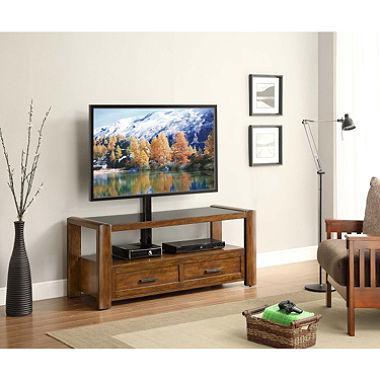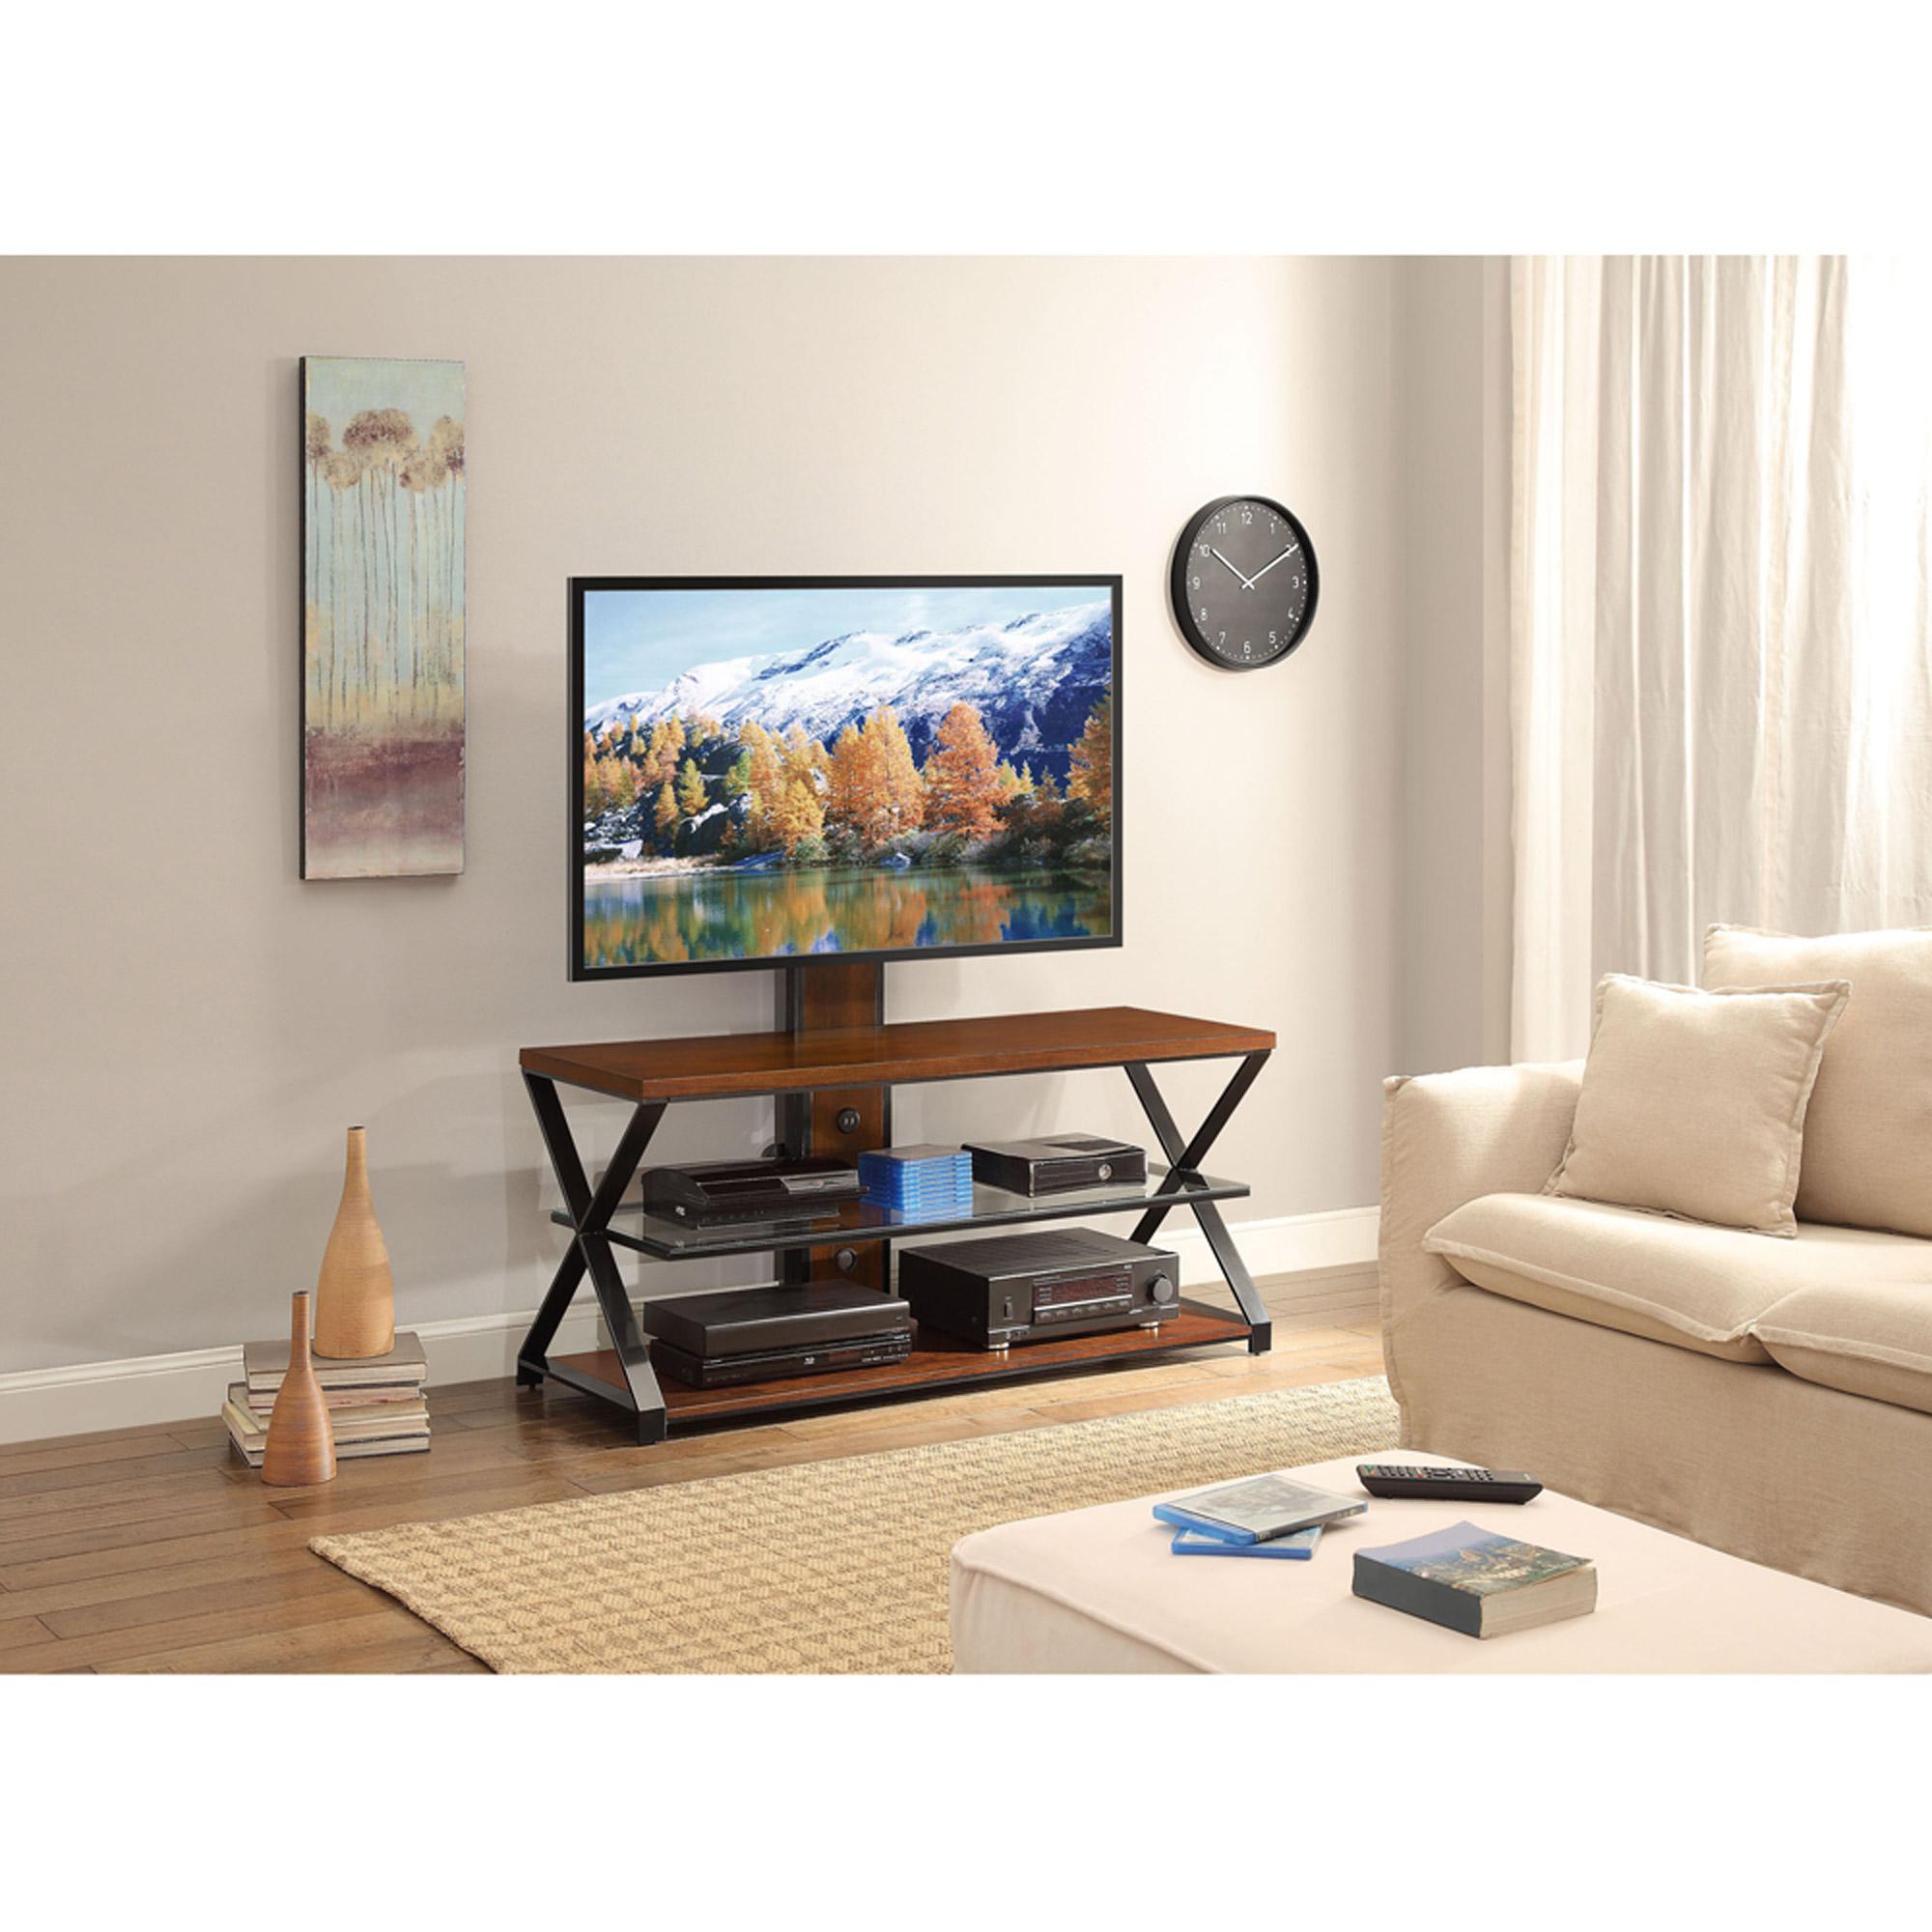The first image is the image on the left, the second image is the image on the right. Analyze the images presented: Is the assertion "Both TV stands have three shelves." valid? Answer yes or no. No. The first image is the image on the left, the second image is the image on the right. Analyze the images presented: Is the assertion "The right image features a TV stand with Z-shaped ends formed by a curved diagonal piece, and the left image features a stand with at least one X-shape per end." valid? Answer yes or no. No. 